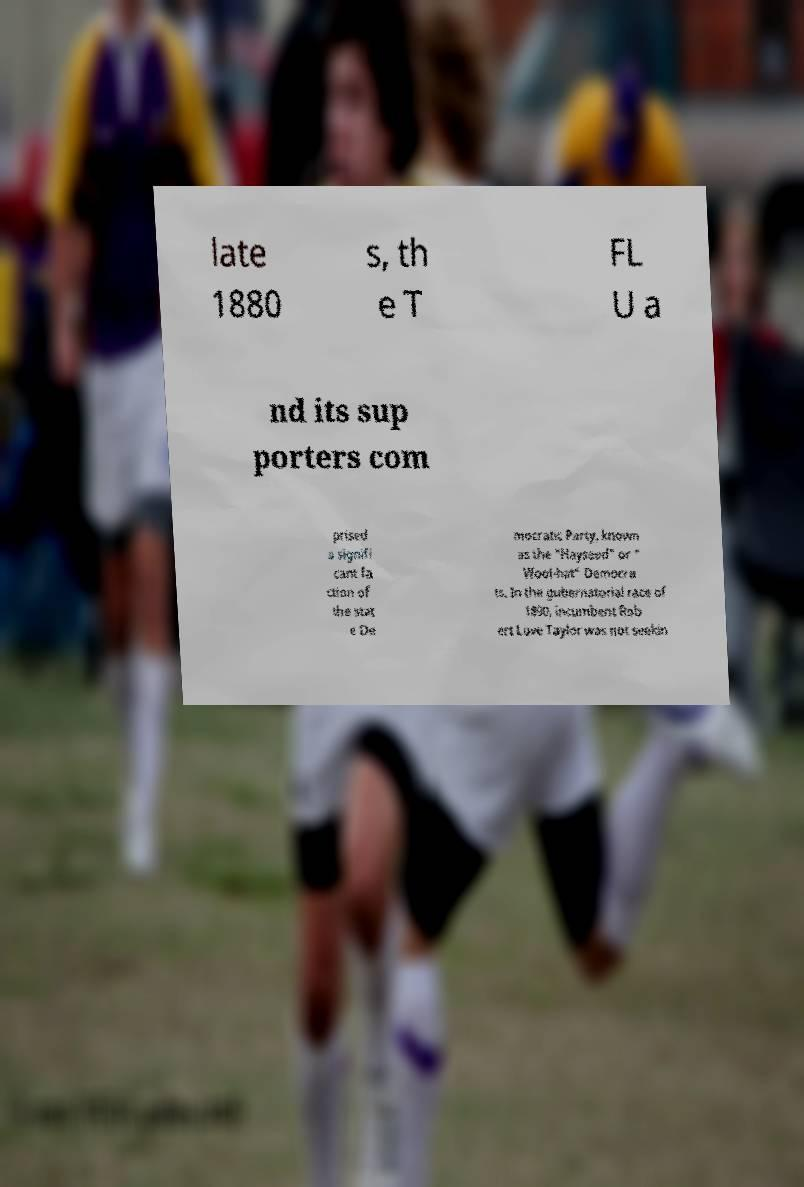Could you assist in decoding the text presented in this image and type it out clearly? late 1880 s, th e T FL U a nd its sup porters com prised a signifi cant fa ction of the stat e De mocratic Party, known as the "Hayseed" or " Wool-hat" Democra ts. In the gubernatorial race of 1890, incumbent Rob ert Love Taylor was not seekin 